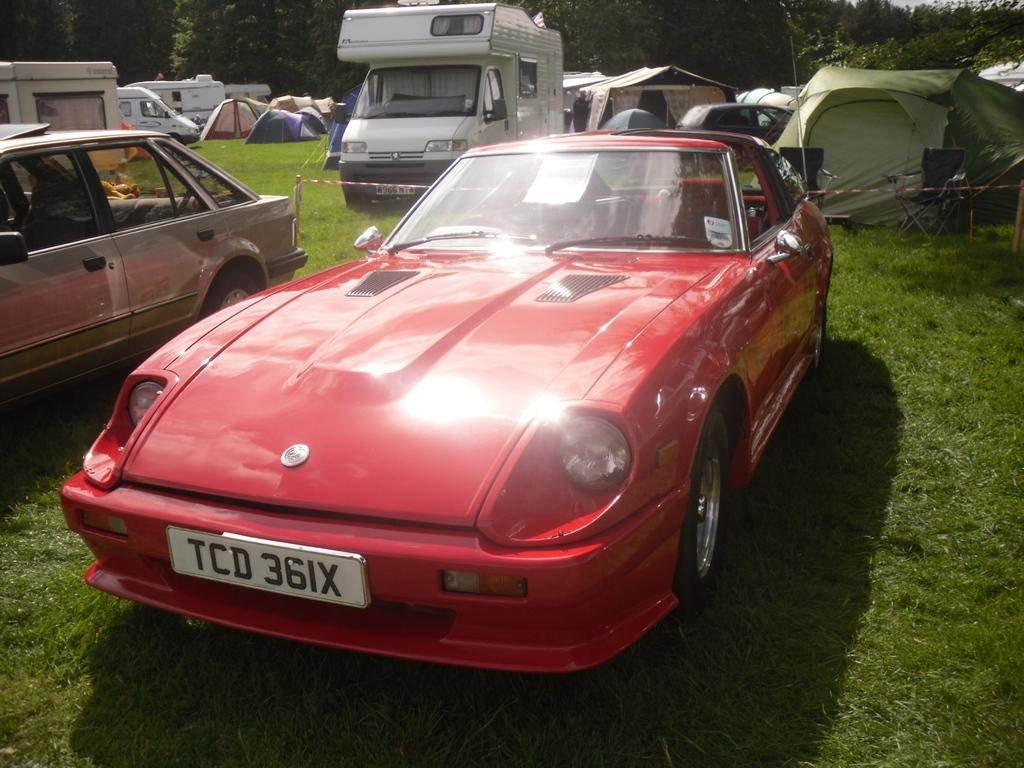What is the main subject of the image? The main subject of the image is a car. What type of natural vegetation is visible in the image? There are trees in the image. What type of structures can be seen in the image? There are sheds in the image. What type of ground surface is visible in the image? There is grass in the image. What type of furniture is present in the image? There is a chair in the image. How many beds are visible in the image? There are no beds present in the image. What type of chalk is being used to draw on the chair in the image? There is no chalk present in the image, and the chair is not being used for drawing. --- Facts: 1. There is a person holding a book in the image. 2. The person is sitting on a bench. 3. There is a tree in the background of the image. 4. There is a river in the background of the image. 5. The person is wearing a hat. Absurd Topics: parrot, bicycle, fireplace Conversation: What is the person in the image holding? The person in the image is holding a book. Where is the person sitting in the image? The person is sitting on a bench. What type of natural vegetation is visible in the background of the image? There is a tree in the background of the image. What type of body of water is visible in the background of the image? There is a river in the background of the image. What type of headwear is the person wearing in the image? The person is wearing a hat. Reasoning: Let's think step by step in order to produce the conversation. We start by identifying the main subject of the image, which is the person holding a book. Then, we describe the person's actions and location, such as sitting on a bench. Next, we describe the natural elements in the background, such as the tree and river. Finally, we describe the person's attire, specifically their hat. Each question is designed to elicit a specific detail about the image that is known from the provided facts. Absurd Question/Answer: What type of parrot is sitting on the person's shoulder in the image? There is no parrot present in the image. What type of bicycle is the person riding in the image? There is no bicycle present in the image. Where is the fireplace located in the image? There is no fireplace present in the image. 